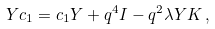<formula> <loc_0><loc_0><loc_500><loc_500>Y c _ { 1 } = c _ { 1 } Y + q ^ { 4 } I - q ^ { 2 } \lambda Y K \, ,</formula> 